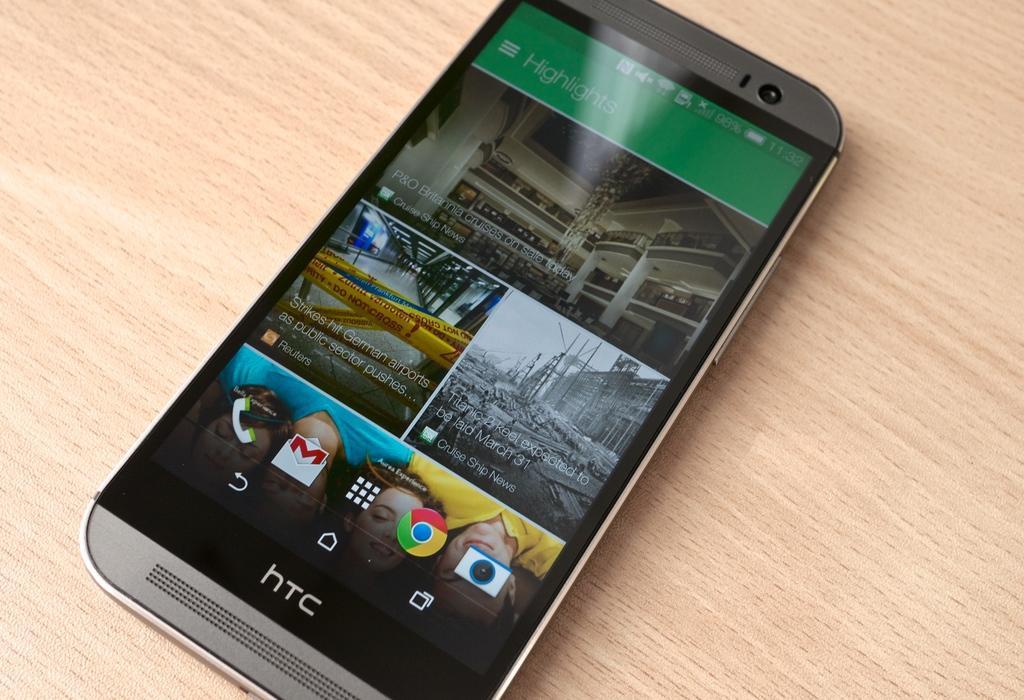Describe this image in one or two sentences. In the picture we can see a mobile phone on the wooden plank with a brand name hats on it with some options on the screen. 